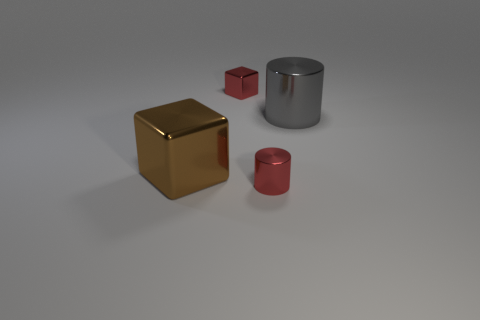Add 1 metallic cylinders. How many objects exist? 5 Subtract all cubes. Subtract all large red matte balls. How many objects are left? 2 Add 2 small red shiny things. How many small red shiny things are left? 4 Add 2 tiny red matte spheres. How many tiny red matte spheres exist? 2 Subtract 0 brown cylinders. How many objects are left? 4 Subtract all brown cubes. Subtract all blue spheres. How many cubes are left? 1 